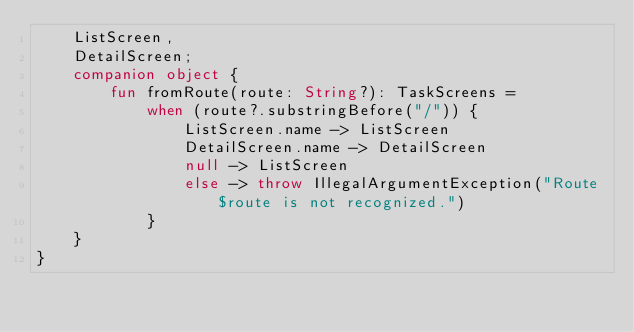Convert code to text. <code><loc_0><loc_0><loc_500><loc_500><_Kotlin_>    ListScreen,
    DetailScreen;
    companion object {
        fun fromRoute(route: String?): TaskScreens =
            when (route?.substringBefore("/")) {
                ListScreen.name -> ListScreen
                DetailScreen.name -> DetailScreen
                null -> ListScreen
                else -> throw IllegalArgumentException("Route $route is not recognized.")
            }
    }
}</code> 